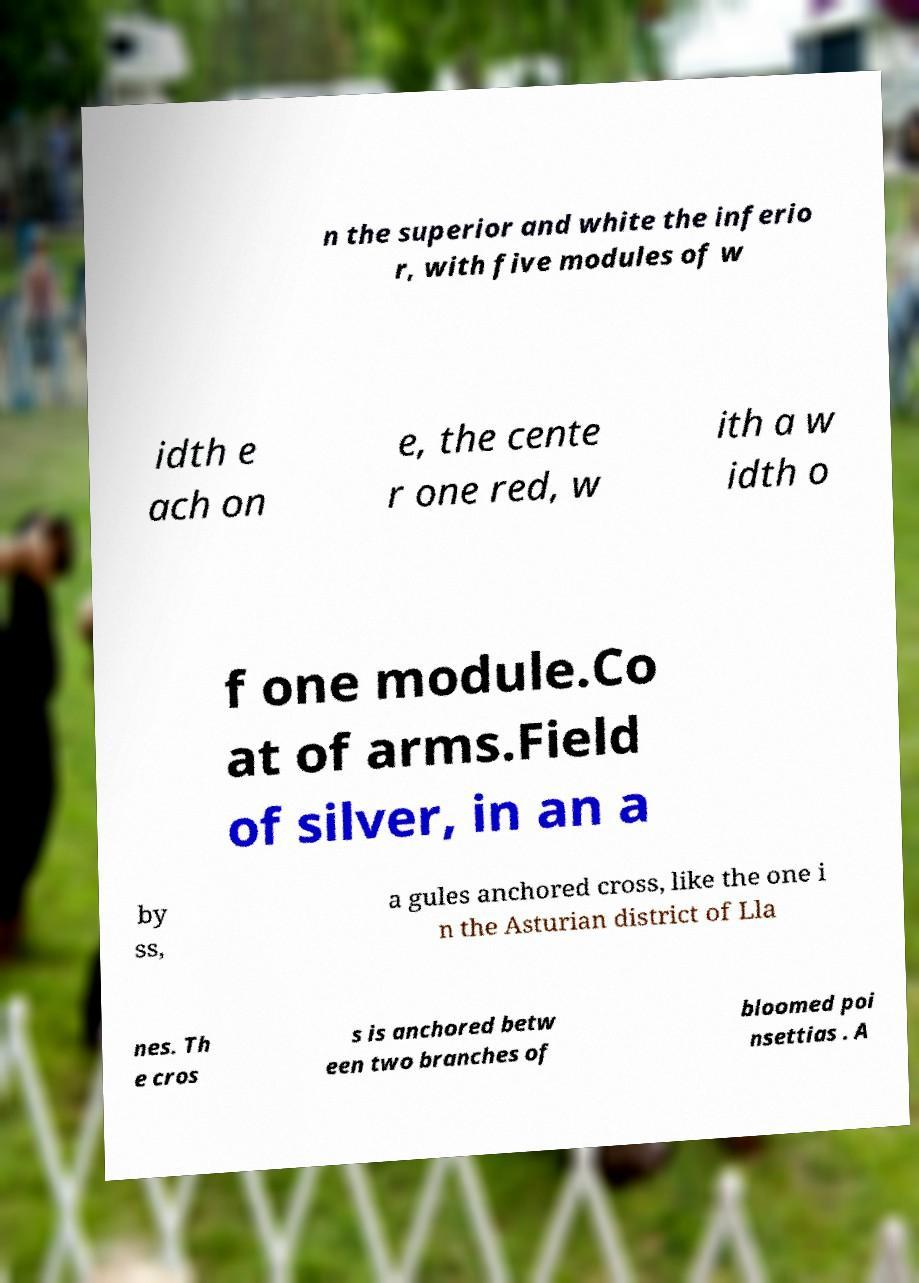Can you read and provide the text displayed in the image?This photo seems to have some interesting text. Can you extract and type it out for me? n the superior and white the inferio r, with five modules of w idth e ach on e, the cente r one red, w ith a w idth o f one module.Co at of arms.Field of silver, in an a by ss, a gules anchored cross, like the one i n the Asturian district of Lla nes. Th e cros s is anchored betw een two branches of bloomed poi nsettias . A 